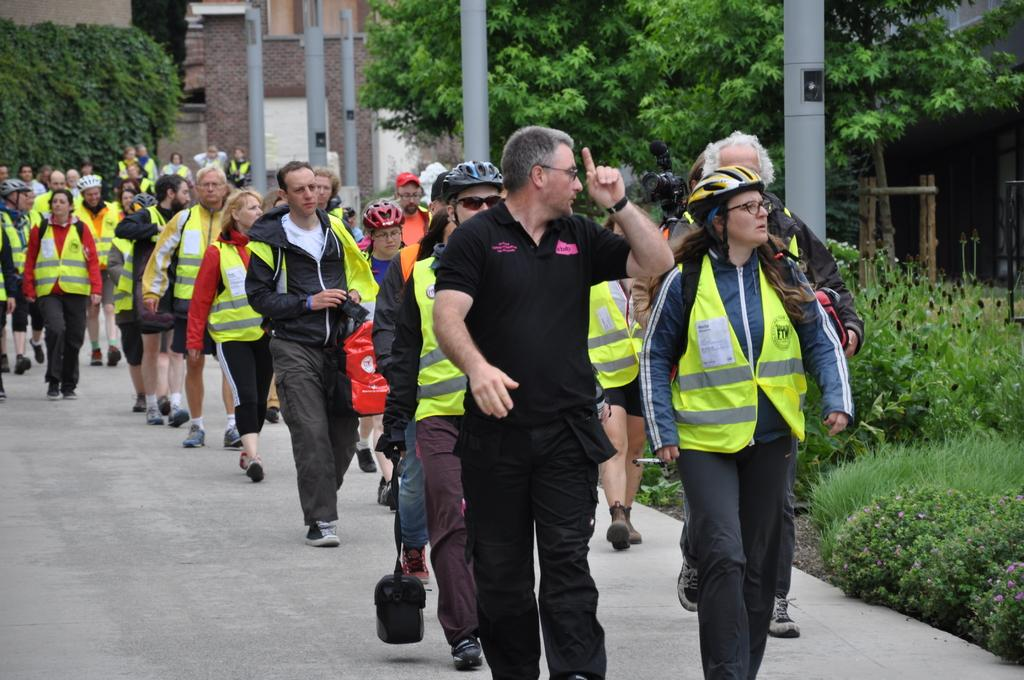What are the people in the image doing? The people in the image are walking on a path. What can be seen on the right side of the image? There are plants, trees, and poles on the right side of the image. What is visible in the background of the image? There is a building and a plant in the background of the image. How many eyes can be seen on the station in the image? There is no station present in the image, and therefore no eyes can be seen. 